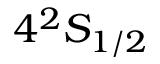<formula> <loc_0><loc_0><loc_500><loc_500>4 ^ { 2 } S _ { 1 / 2 }</formula> 